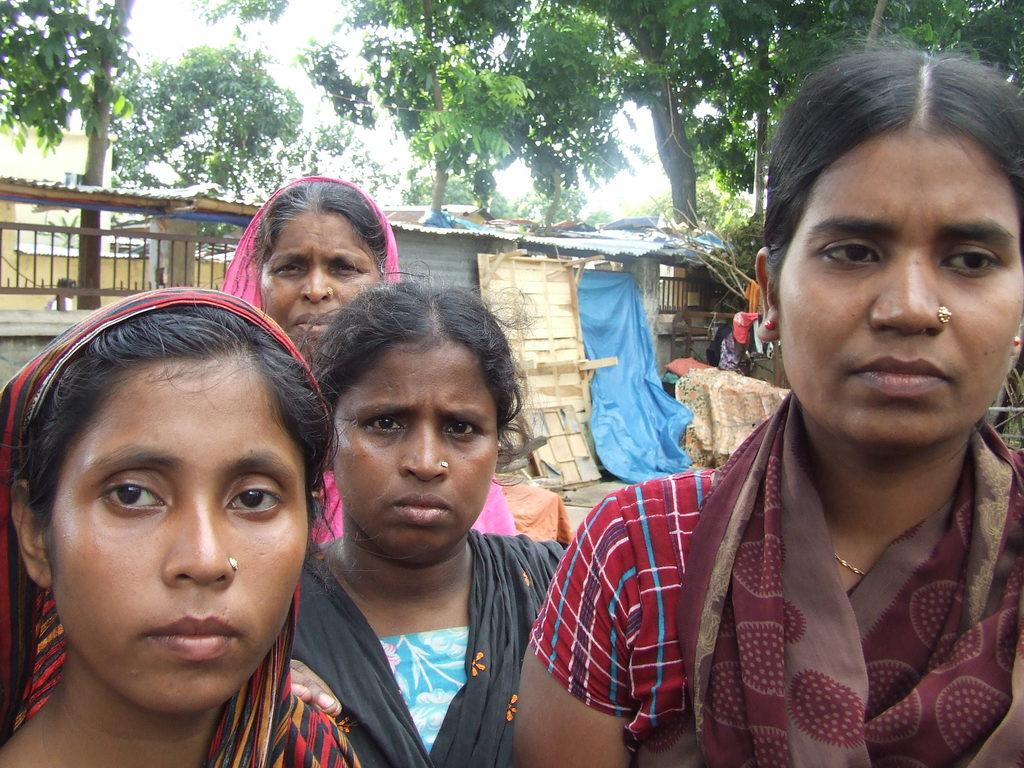How many women are present in the image? There are four women in the image. What can be seen in the background of the image? There are huts, railings, and trees in the background of the image. What color is the sheet visible in the image? There is a blue color sheet in the image. What type of zinc is being used to build the huts in the image? There is no information about the materials used to build the huts in the image, so it cannot be determined if zinc is being used. 